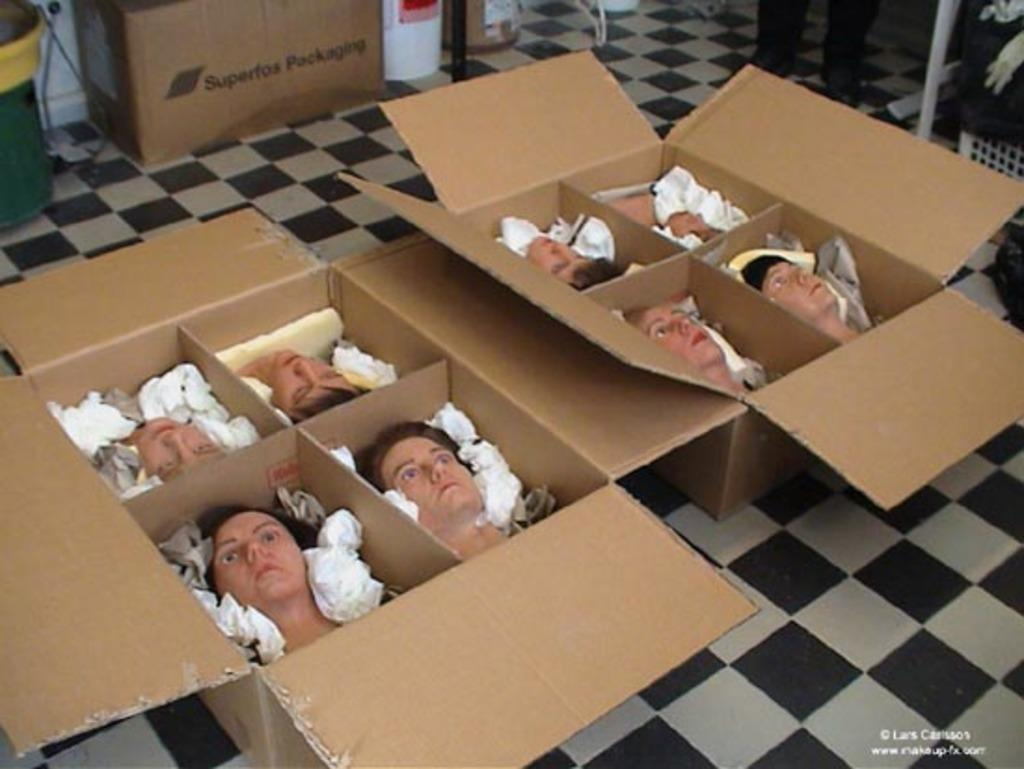What objects are present in the image? There are doll heads in the image. How are the doll heads stored or organized? The doll heads are packed in cardboard boxes. What type of yarn is being used by the monkey in the image? There is no monkey or yarn present in the image; it only features doll heads packed in cardboard boxes. 